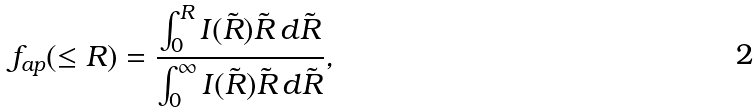Convert formula to latex. <formula><loc_0><loc_0><loc_500><loc_500>f _ { a p } ( \leq R ) = \frac { \int _ { 0 } ^ { R } I ( \tilde { R } ) \tilde { R } \, d \tilde { R } } { \int _ { 0 } ^ { \infty } I ( \tilde { R } ) \tilde { R } \, d \tilde { R } } ,</formula> 